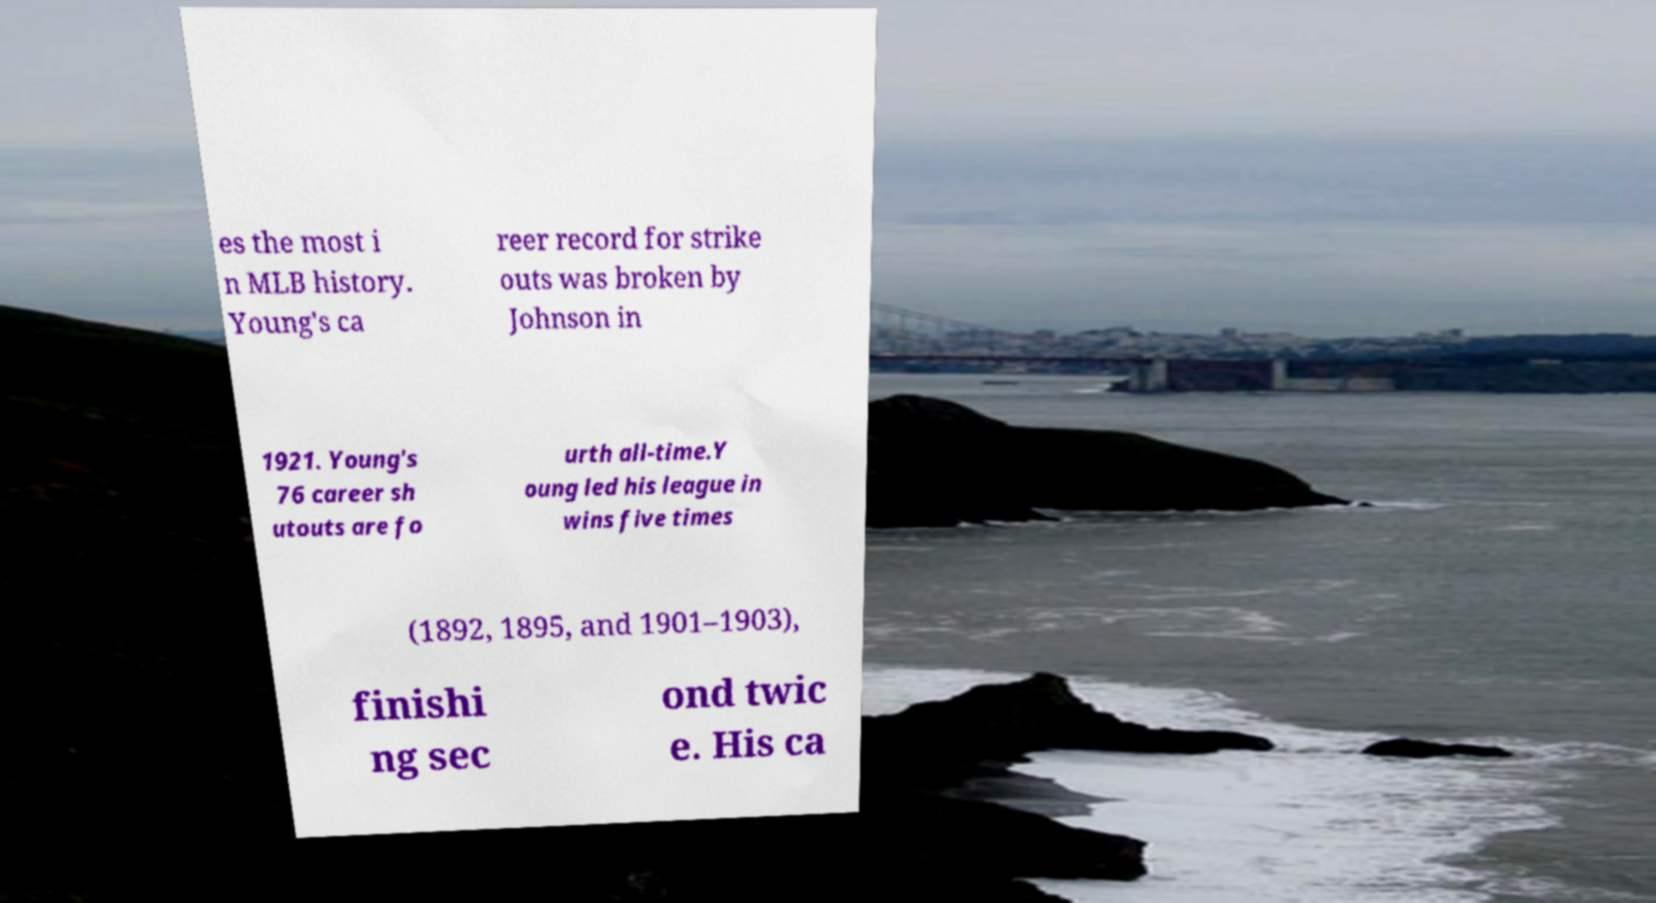Please read and relay the text visible in this image. What does it say? es the most i n MLB history. Young's ca reer record for strike outs was broken by Johnson in 1921. Young's 76 career sh utouts are fo urth all-time.Y oung led his league in wins five times (1892, 1895, and 1901–1903), finishi ng sec ond twic e. His ca 